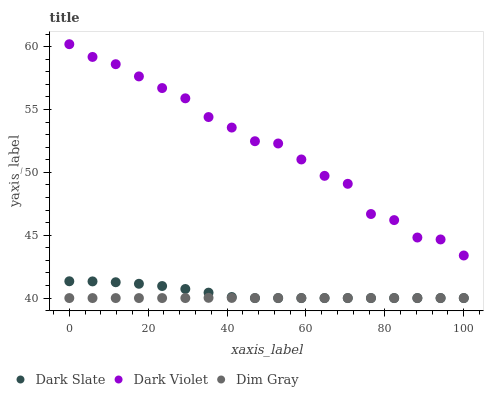Does Dim Gray have the minimum area under the curve?
Answer yes or no. Yes. Does Dark Violet have the maximum area under the curve?
Answer yes or no. Yes. Does Dark Violet have the minimum area under the curve?
Answer yes or no. No. Does Dim Gray have the maximum area under the curve?
Answer yes or no. No. Is Dim Gray the smoothest?
Answer yes or no. Yes. Is Dark Violet the roughest?
Answer yes or no. Yes. Is Dark Violet the smoothest?
Answer yes or no. No. Is Dim Gray the roughest?
Answer yes or no. No. Does Dark Slate have the lowest value?
Answer yes or no. Yes. Does Dark Violet have the lowest value?
Answer yes or no. No. Does Dark Violet have the highest value?
Answer yes or no. Yes. Does Dim Gray have the highest value?
Answer yes or no. No. Is Dim Gray less than Dark Violet?
Answer yes or no. Yes. Is Dark Violet greater than Dim Gray?
Answer yes or no. Yes. Does Dark Slate intersect Dim Gray?
Answer yes or no. Yes. Is Dark Slate less than Dim Gray?
Answer yes or no. No. Is Dark Slate greater than Dim Gray?
Answer yes or no. No. Does Dim Gray intersect Dark Violet?
Answer yes or no. No. 